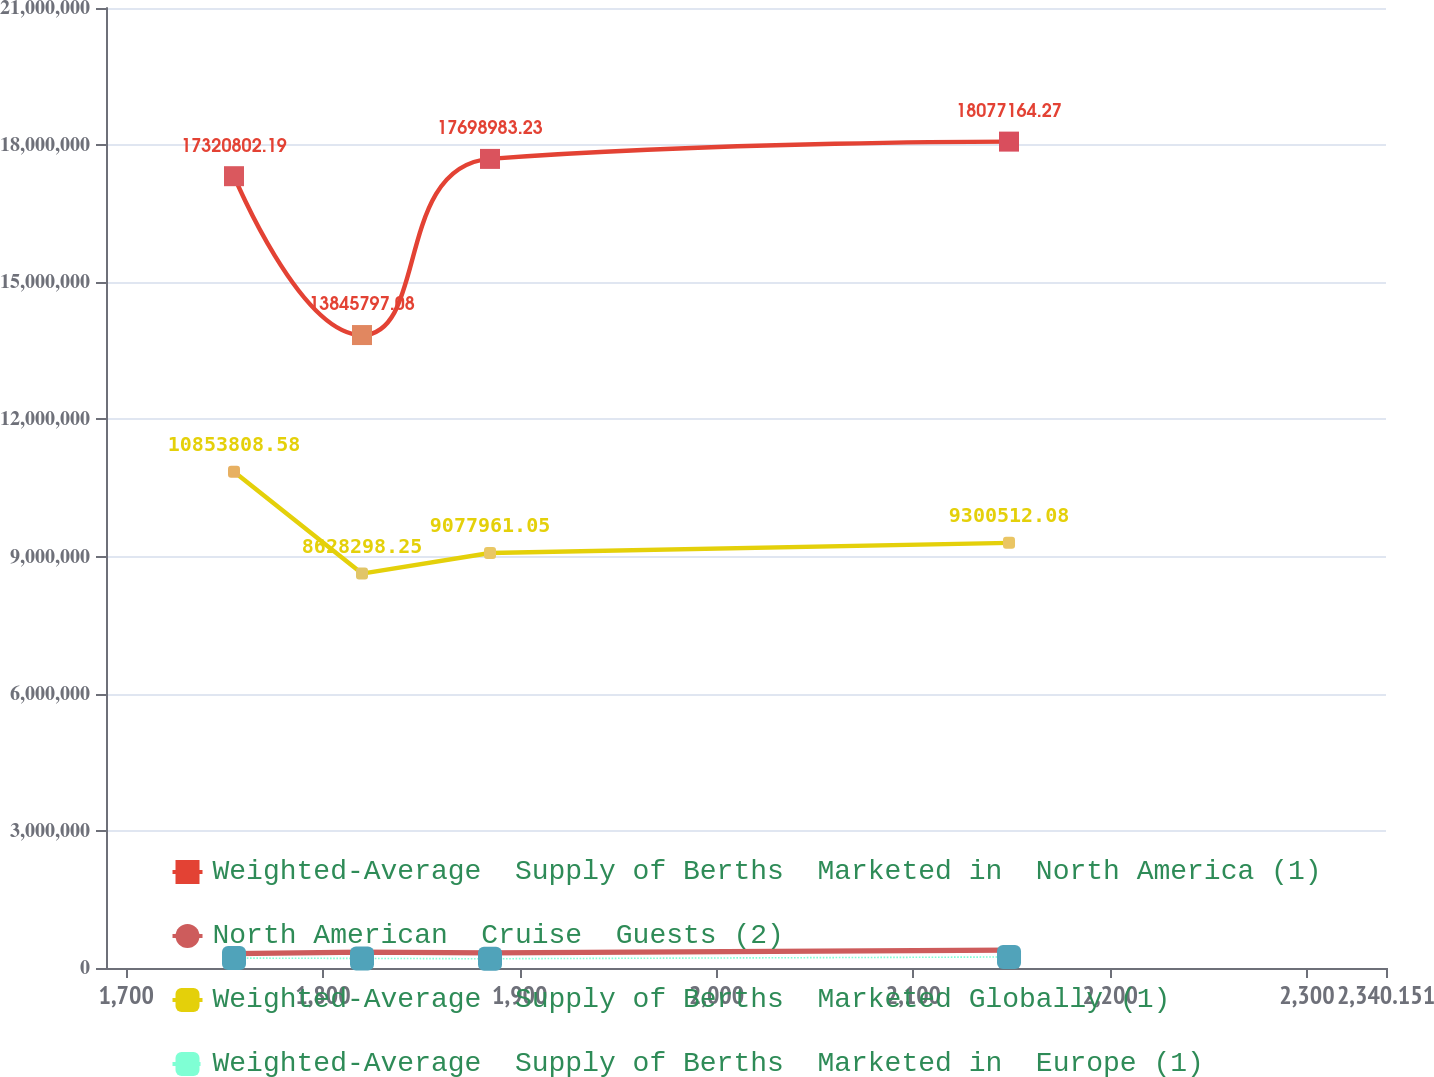Convert chart. <chart><loc_0><loc_0><loc_500><loc_500><line_chart><ecel><fcel>Weighted-Average  Supply of Berths  Marketed in  North America (1)<fcel>North American  Cruise  Guests (2)<fcel>Weighted-Average  Supply of Berths  Marketed Globally (1)<fcel>Weighted-Average  Supply of Berths  Marketed in  Europe (1)<nl><fcel>1754.8<fcel>1.73208e+07<fcel>313191<fcel>1.08538e+07<fcel>217009<nl><fcel>1819.84<fcel>1.38458e+07<fcel>349047<fcel>8.6283e+06<fcel>209555<nl><fcel>1884.88<fcel>1.7699e+07<fcel>331880<fcel>9.07796e+06<fcel>202100<nl><fcel>2148.6<fcel>1.80772e+07<fcel>391085<fcel>9.30051e+06<fcel>241144<nl><fcel>2405.19<fcel>1.6694e+07<fcel>356836<fcel>9.91138e+06<fcel>276642<nl></chart> 